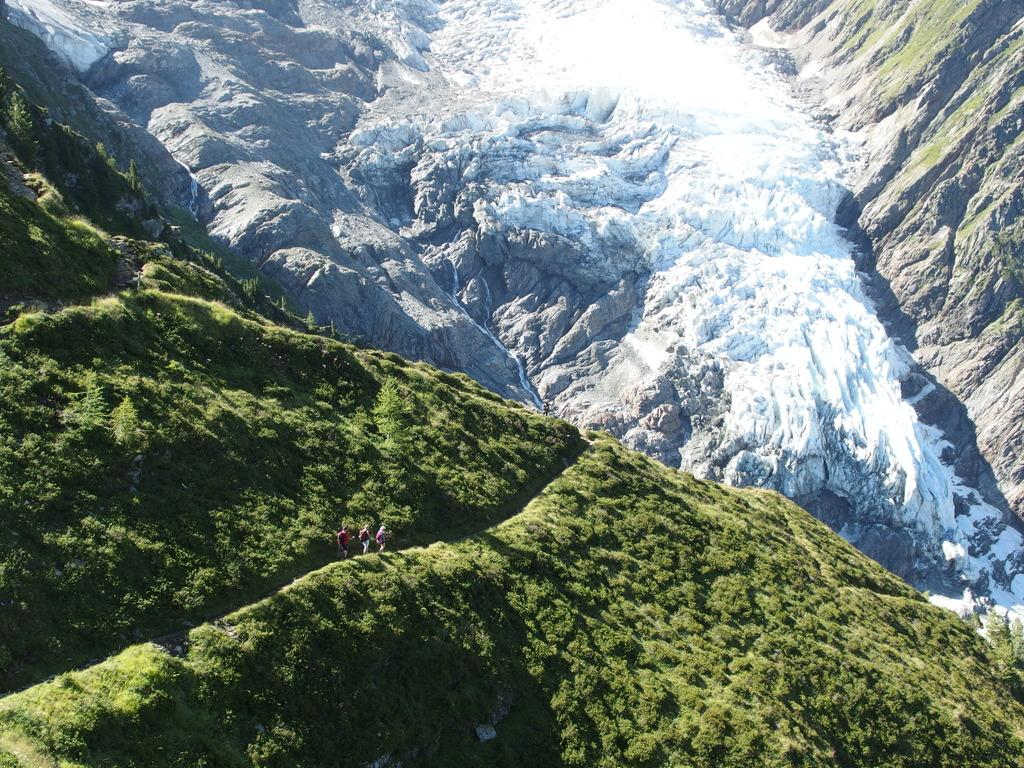How many people are in the image? There are three persons in the image. What type of natural environment is visible in the image? There is grass and plants in the image, suggesting a natural setting. What other objects can be seen in the image? There are rocks in the image. What type of payment method is being used by the representative in the image? There is no representative or payment method present in the image. What authority figure can be seen in the image? There is no authority figure present in the image. 